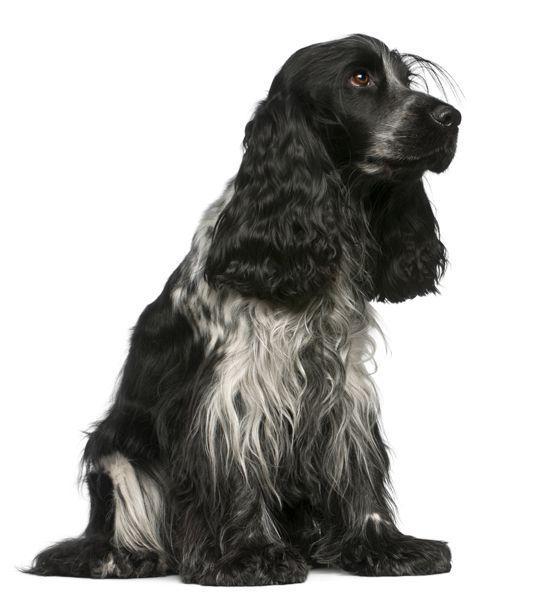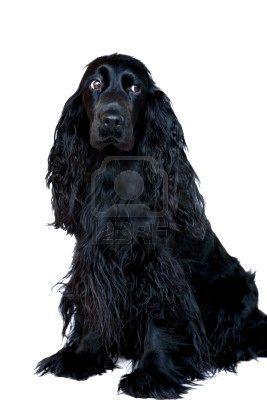The first image is the image on the left, the second image is the image on the right. Considering the images on both sides, is "The image on the right shows more than two dogs." valid? Answer yes or no. No. The first image is the image on the left, the second image is the image on the right. Evaluate the accuracy of this statement regarding the images: "There are no less than three dogs visible". Is it true? Answer yes or no. No. 